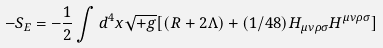<formula> <loc_0><loc_0><loc_500><loc_500>- S _ { E } = - \frac { 1 } { 2 } \int d ^ { 4 } x \sqrt { + g } [ ( R + 2 \Lambda ) + ( 1 / 4 8 ) H _ { \mu \nu \rho \sigma } H ^ { \mu \nu \rho \sigma } ]</formula> 